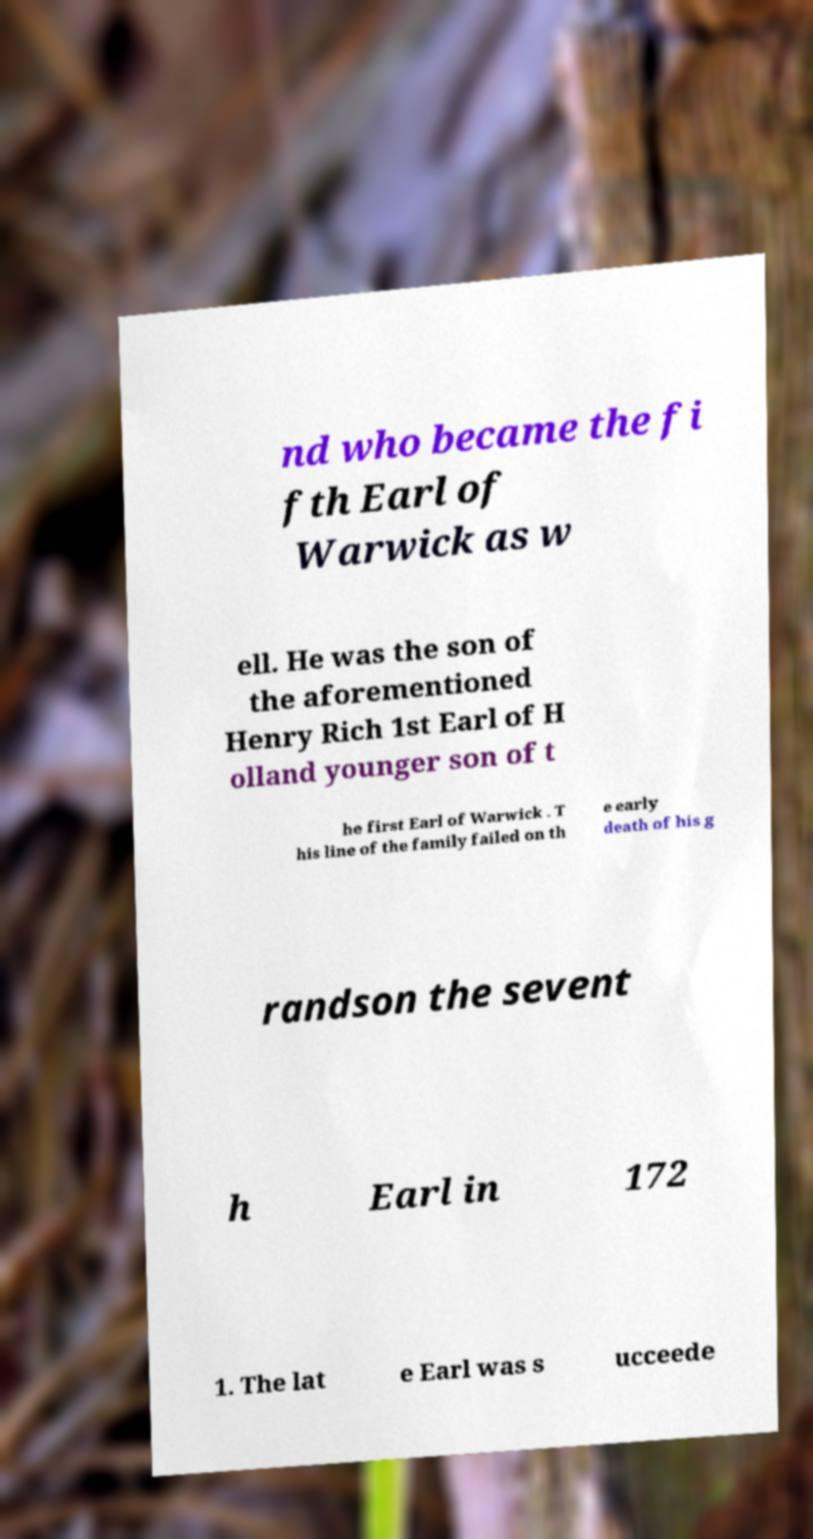For documentation purposes, I need the text within this image transcribed. Could you provide that? nd who became the fi fth Earl of Warwick as w ell. He was the son of the aforementioned Henry Rich 1st Earl of H olland younger son of t he first Earl of Warwick . T his line of the family failed on th e early death of his g randson the sevent h Earl in 172 1. The lat e Earl was s ucceede 